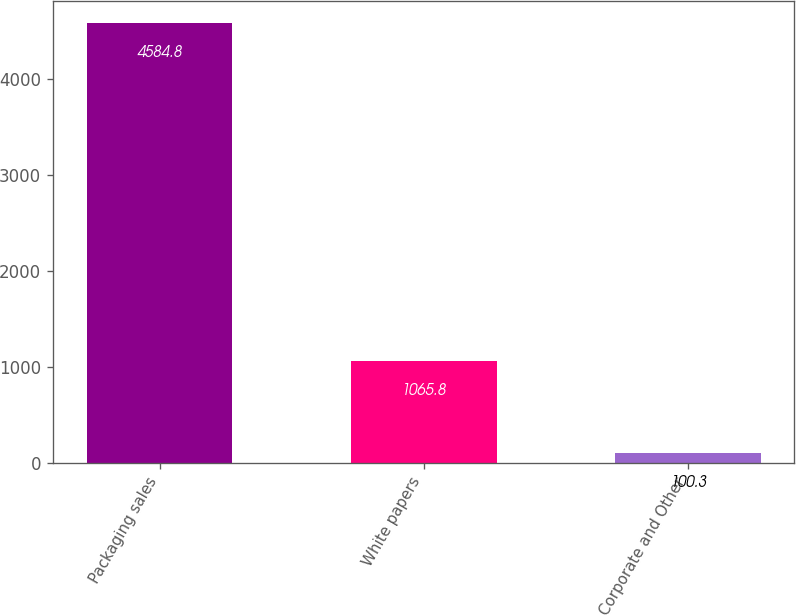Convert chart. <chart><loc_0><loc_0><loc_500><loc_500><bar_chart><fcel>Packaging sales<fcel>White papers<fcel>Corporate and Other<nl><fcel>4584.8<fcel>1065.8<fcel>100.3<nl></chart> 